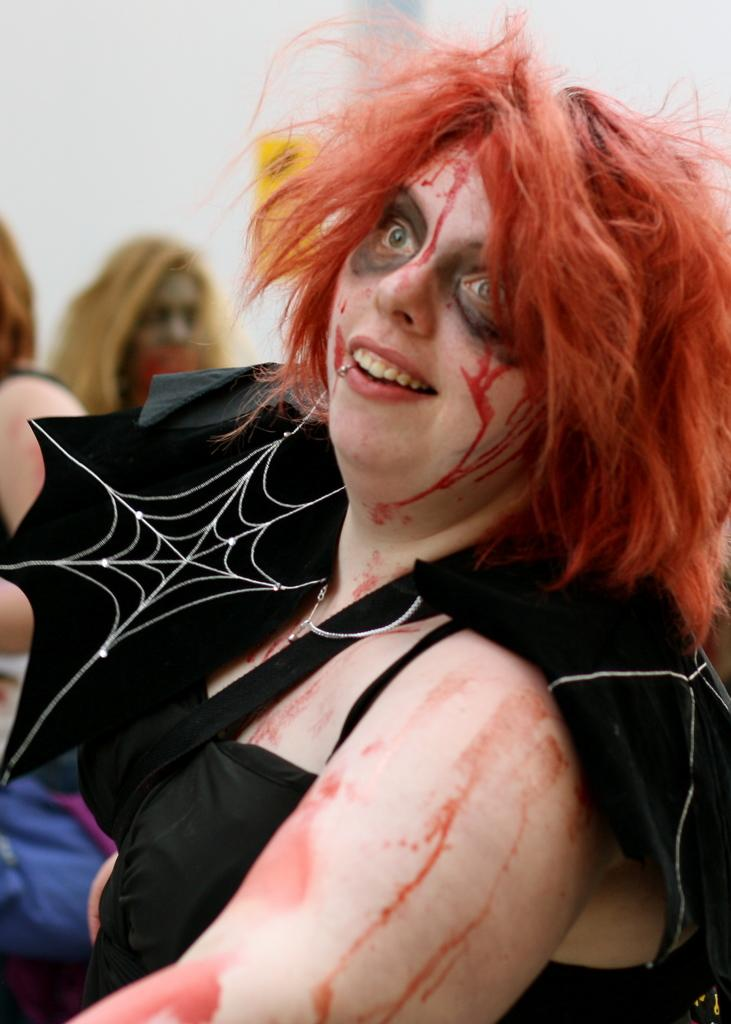What is the person in the foreground of the image wearing? The person in the image is wearing a black dress. Can you describe the people in the background of the image? There are other persons sitting in the background of the image. What color is the wall in the background? The wall in the background is white. What type of can is visible on the person's arm in the image? There is no can visible on the person's arm in the image. What type of lace is used to decorate the person's dress in the image? The person's dress in the image is a black dress, and there is no mention of lace in the provided facts. 